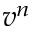<formula> <loc_0><loc_0><loc_500><loc_500>v ^ { n }</formula> 